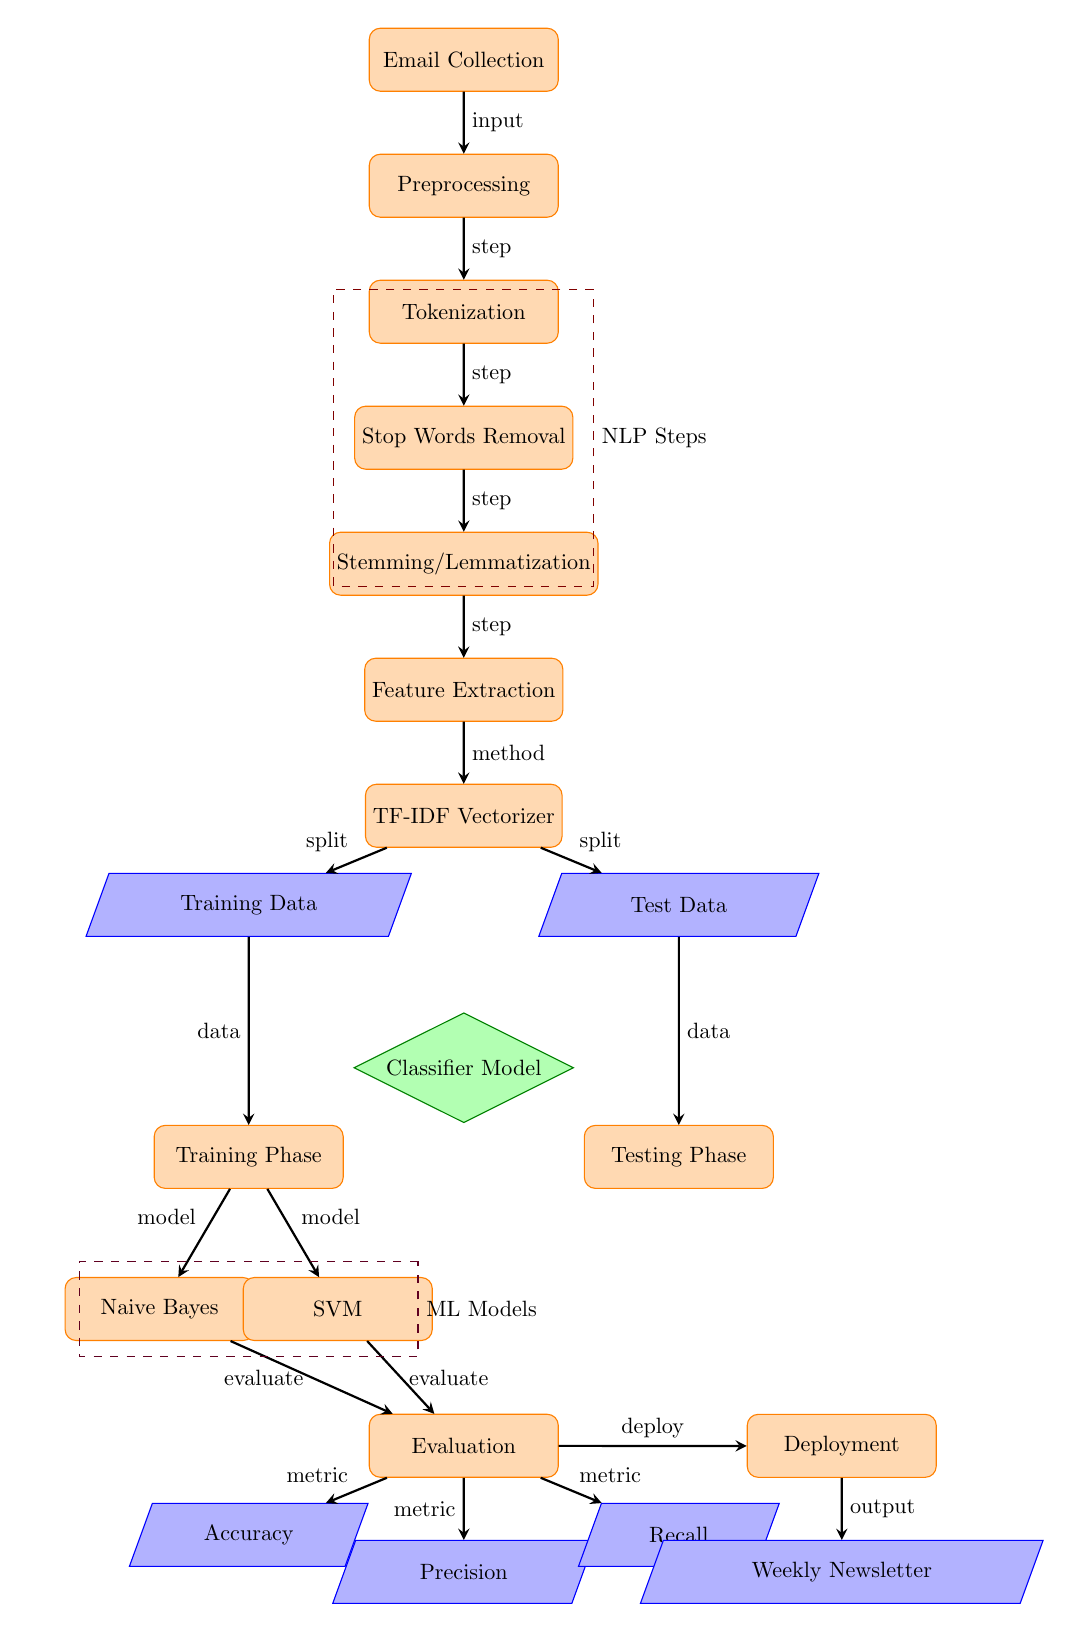What is the first step in the process? The diagram starts with the node labeled "Email Collection," indicating that the first step is to collect emails.
Answer: Email Collection How many machine learning model options are presented in the diagram? The diagram shows two choices for the model at the node labeled "Classifier Model," which are Naive Bayes and SVM.
Answer: 2 What type of data is provided to the "Training Phase"? The "Training Phase" receives data from the "Training Data" node as indicated by the arrow leading into it.
Answer: Training Data Which step involves feature extraction? The node labeled "Feature Extraction" outlines the process for obtaining relevant features from the email content, indicating this step is where feature extraction occurs.
Answer: Feature Extraction What metrics are evaluated after the training phase? The evaluation step includes three metrics: Accuracy, Precision, and Recall, which are shown as output from the Evaluation node.
Answer: Accuracy, Precision, Recall What are the two technologies used for classification? The two classification methods shown at the "Classifier Model" are Naive Bayes and SVM, as depicted in the branches leading down to them.
Answer: Naive Bayes, SVM Which process is directly before "Feature Extraction"? The diagram shows "Stemming/Lemmatization" as the process that comes right before "Feature Extraction."
Answer: Stemming/Lemmatization What does the "Deployment" step lead to? The "Deployment" step leads to the final output, which is labeled as "Weekly Newsletter," signifying the application of the model's results.
Answer: Weekly Newsletter What is the purpose of the "TF-IDF Vectorizer"? The "TF-IDF Vectorizer" is utilized to process the features extracted from the emails, transforming them into numerical vector form for classification.
Answer: Feature extraction method 